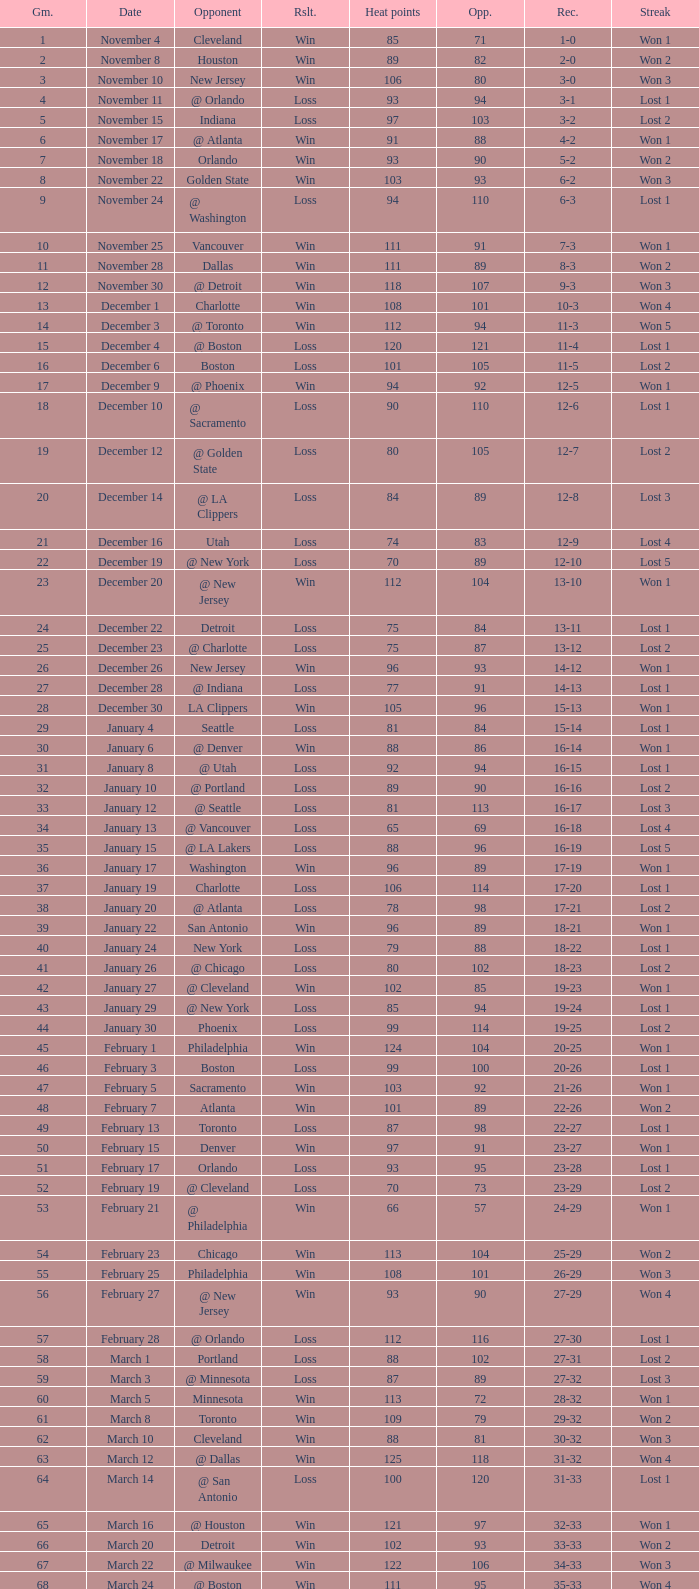What is Streak, when Heat Points is "101", and when Game is "16"? Lost 2. 